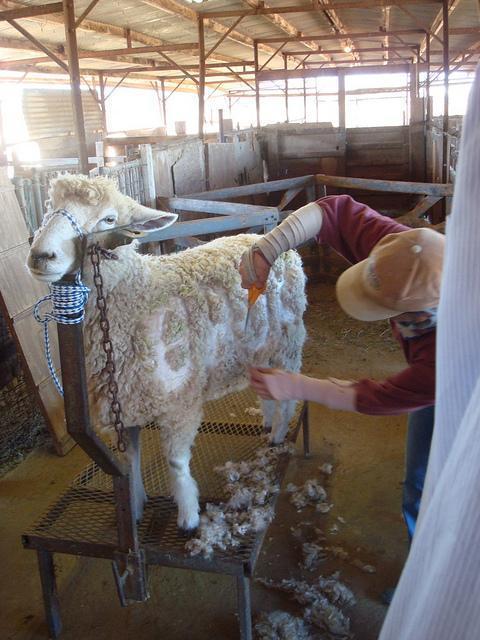Verify the accuracy of this image caption: "The person is touching the sheep.".
Answer yes or no. Yes. Evaluate: Does the caption "The person is alongside the sheep." match the image?
Answer yes or no. Yes. 